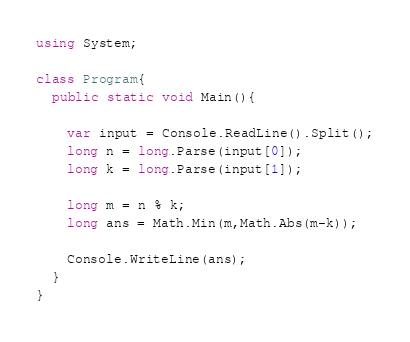Convert code to text. <code><loc_0><loc_0><loc_500><loc_500><_C#_>using System;

class Program{
  public static void Main(){
    
    var input = Console.ReadLine().Split();
    long n = long.Parse(input[0]);
    long k = long.Parse(input[1]);
    
    long m = n % k;
    long ans = Math.Min(m,Math.Abs(m-k));
    
    Console.WriteLine(ans);
  }
}</code> 